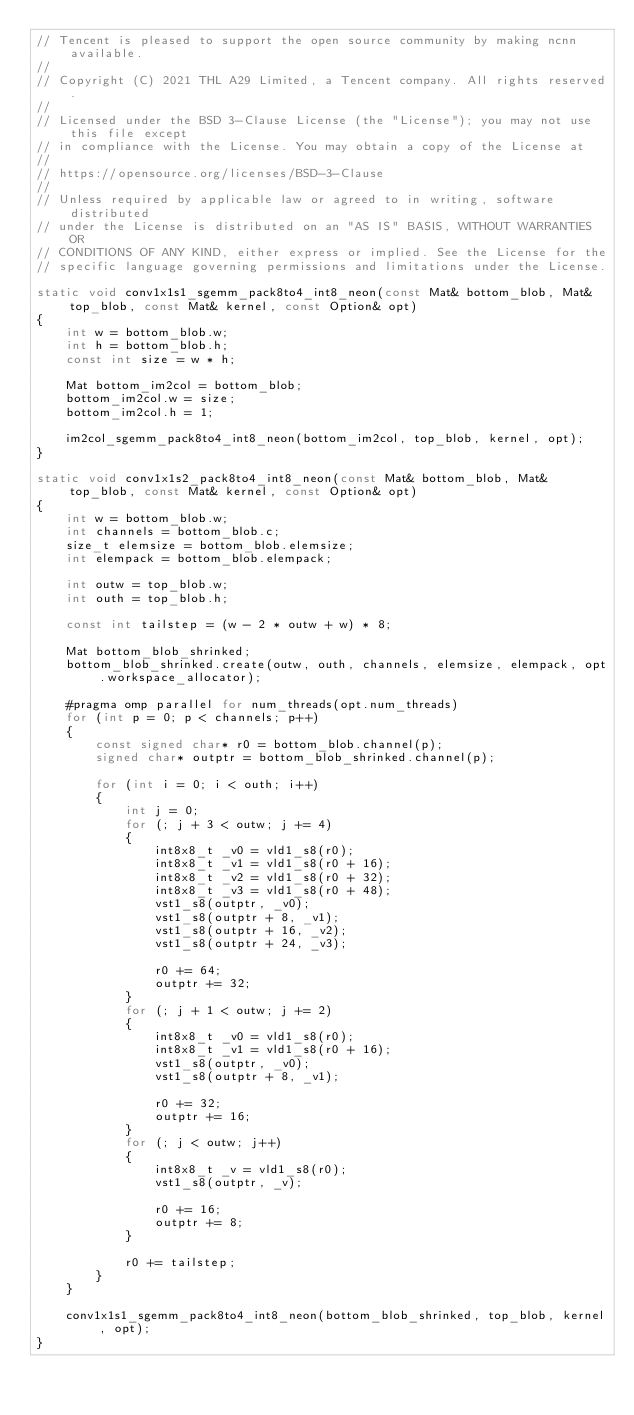Convert code to text. <code><loc_0><loc_0><loc_500><loc_500><_C_>// Tencent is pleased to support the open source community by making ncnn available.
//
// Copyright (C) 2021 THL A29 Limited, a Tencent company. All rights reserved.
//
// Licensed under the BSD 3-Clause License (the "License"); you may not use this file except
// in compliance with the License. You may obtain a copy of the License at
//
// https://opensource.org/licenses/BSD-3-Clause
//
// Unless required by applicable law or agreed to in writing, software distributed
// under the License is distributed on an "AS IS" BASIS, WITHOUT WARRANTIES OR
// CONDITIONS OF ANY KIND, either express or implied. See the License for the
// specific language governing permissions and limitations under the License.

static void conv1x1s1_sgemm_pack8to4_int8_neon(const Mat& bottom_blob, Mat& top_blob, const Mat& kernel, const Option& opt)
{
    int w = bottom_blob.w;
    int h = bottom_blob.h;
    const int size = w * h;

    Mat bottom_im2col = bottom_blob;
    bottom_im2col.w = size;
    bottom_im2col.h = 1;

    im2col_sgemm_pack8to4_int8_neon(bottom_im2col, top_blob, kernel, opt);
}

static void conv1x1s2_pack8to4_int8_neon(const Mat& bottom_blob, Mat& top_blob, const Mat& kernel, const Option& opt)
{
    int w = bottom_blob.w;
    int channels = bottom_blob.c;
    size_t elemsize = bottom_blob.elemsize;
    int elempack = bottom_blob.elempack;

    int outw = top_blob.w;
    int outh = top_blob.h;

    const int tailstep = (w - 2 * outw + w) * 8;

    Mat bottom_blob_shrinked;
    bottom_blob_shrinked.create(outw, outh, channels, elemsize, elempack, opt.workspace_allocator);

    #pragma omp parallel for num_threads(opt.num_threads)
    for (int p = 0; p < channels; p++)
    {
        const signed char* r0 = bottom_blob.channel(p);
        signed char* outptr = bottom_blob_shrinked.channel(p);

        for (int i = 0; i < outh; i++)
        {
            int j = 0;
            for (; j + 3 < outw; j += 4)
            {
                int8x8_t _v0 = vld1_s8(r0);
                int8x8_t _v1 = vld1_s8(r0 + 16);
                int8x8_t _v2 = vld1_s8(r0 + 32);
                int8x8_t _v3 = vld1_s8(r0 + 48);
                vst1_s8(outptr, _v0);
                vst1_s8(outptr + 8, _v1);
                vst1_s8(outptr + 16, _v2);
                vst1_s8(outptr + 24, _v3);

                r0 += 64;
                outptr += 32;
            }
            for (; j + 1 < outw; j += 2)
            {
                int8x8_t _v0 = vld1_s8(r0);
                int8x8_t _v1 = vld1_s8(r0 + 16);
                vst1_s8(outptr, _v0);
                vst1_s8(outptr + 8, _v1);

                r0 += 32;
                outptr += 16;
            }
            for (; j < outw; j++)
            {
                int8x8_t _v = vld1_s8(r0);
                vst1_s8(outptr, _v);

                r0 += 16;
                outptr += 8;
            }

            r0 += tailstep;
        }
    }

    conv1x1s1_sgemm_pack8to4_int8_neon(bottom_blob_shrinked, top_blob, kernel, opt);
}
</code> 